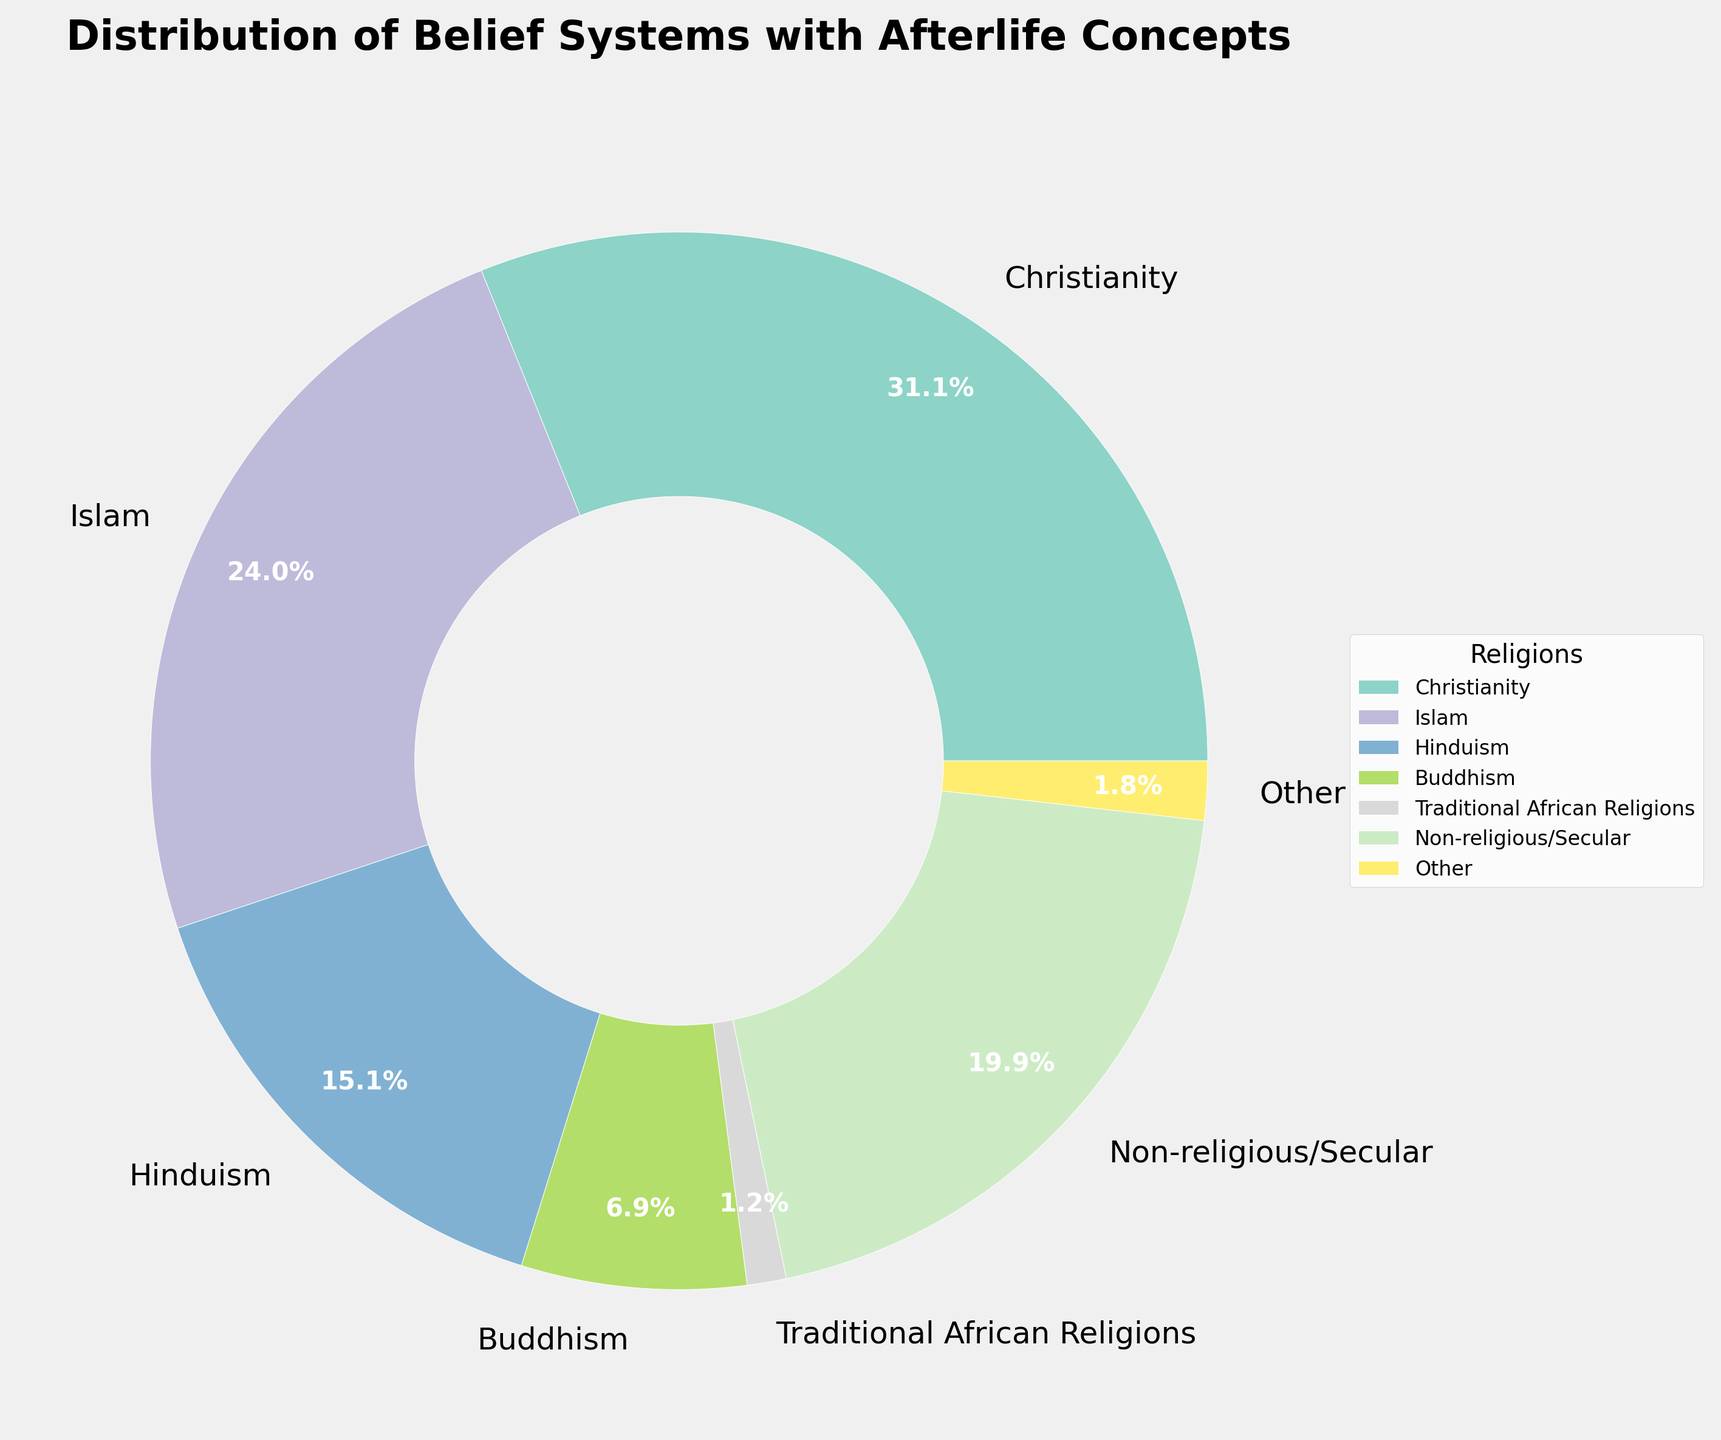What percentage of belief systems with afterlife concepts does Christianity and Islam together account for? Christianity accounts for 31.2% and Islam accounts for 24.1%. Adding these percentages together, 31.2 + 24.1 = 55.3%.
Answer: 55.3% Which belief system has the highest percentage, and which has the lowest measurable percentage? The highest percentage is Christianity at 31.2%, and the lowest measurable percentage is Zoroastrianism at 0.01%. Note that Ancient Egyptian Religion is 0.001%, but it is very close to Zero.
Answer: Christianity and Zoroastrianism How many belief systems are included in the 'Other' category, and what is their combined percentage? The belief systems below the 1% threshold are Sikhism, Judaism, Zoroastrianism, Ancient Egyptian Religion, Spiritualism, Taoism, Shinto, Native American Religions, Jainism, and Baha'i Faith. Adding these percentages gives 0.3 + 0.2 + 0.01 + 0.001 + 0.5 + 0.4 + 0.1 + 0.1 + 0.1 + 0.1 = 1.801%. Rounded to one decimal place, the combined percentage is 1.8%.
Answer: 10 belief systems, 1.8% Which belief system has a percentage closest to the percentage of non-religious/secular people? Non-religious/Secular people account for 20%. Hinduism has the closest percentage at 15.1%. This is closer than any other single belief system.
Answer: Hinduism What is the difference in percentage between Hinduism and non-religious/secular people? Non-religious/Secular is 20.0% and Hinduism is 15.1%. The difference is calculated as 20.0 - 15.1 = 4.9%.
Answer: 4.9% Which belief system has a slightly lower percentage than Judaism, and what is its percentage? Spiritualism has a percentage slightly lower than Judaism, which is 0.5%. Judaism is 0.2%, so it is higher, but nothing slightly lower is listed in the data.
Answer: Spiritualism at 0.5% What is the visual color of the wedge representing Buddhism and how large is it compared to Christianity? Buddhism is represented by one of the colors in a range generated by the colormap and occupies 6.9%. Christianity is 31.2%, so Buddhism is shorter. To compare visually, if Christianity is represented by green, Buddhism may be represented by red. Summarizing, Buddhism's wedge is visually less than Christianity's wedge
Answer: Smaller Wedge Comparing Traditional African Religions to the combined ‘Other’ category, which is larger in terms of percentage? Traditional African Religions account for 1.2%, while the 'Other' category combines all under 1%, summing to 1.8%. Thus, 'Other' is larger.
Answer: Other 1.8% How does the pie chart visually differentiate between belief systems with similar percentages, like Taoism, Shinto, and Jainism? The pie chart differentiates between similar percentages using distinct colors from a colormap. Each wedge for Taoism, Shinto, and Jainism is small, and although their sizes might appear similar, different shades or colors will visually separate them.
Answer: Different Colors 